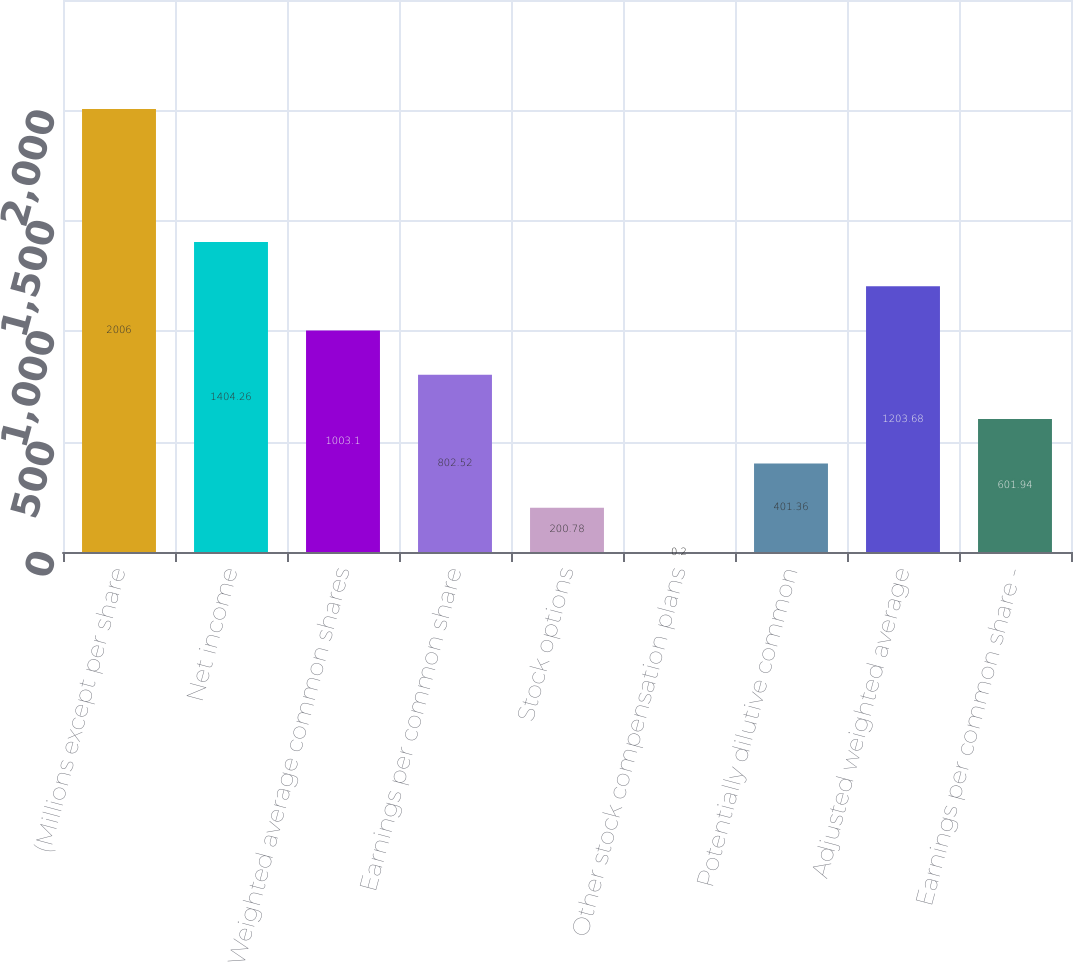<chart> <loc_0><loc_0><loc_500><loc_500><bar_chart><fcel>(Millions except per share<fcel>Net income<fcel>Weighted average common shares<fcel>Earnings per common share<fcel>Stock options<fcel>Other stock compensation plans<fcel>Potentially dilutive common<fcel>Adjusted weighted average<fcel>Earnings per common share -<nl><fcel>2006<fcel>1404.26<fcel>1003.1<fcel>802.52<fcel>200.78<fcel>0.2<fcel>401.36<fcel>1203.68<fcel>601.94<nl></chart> 